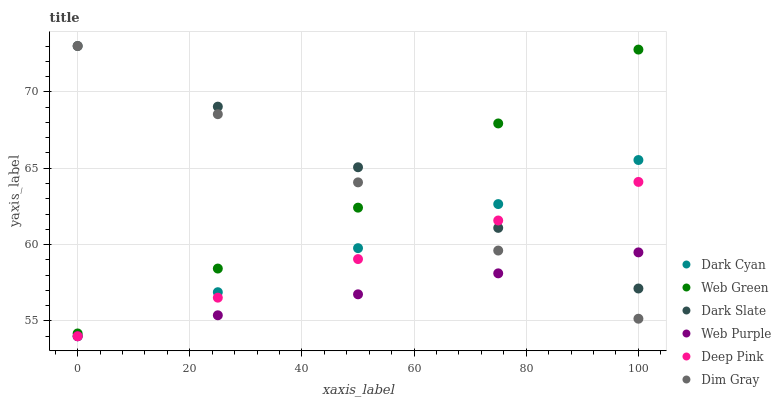Does Web Purple have the minimum area under the curve?
Answer yes or no. Yes. Does Dark Slate have the maximum area under the curve?
Answer yes or no. Yes. Does Web Green have the minimum area under the curve?
Answer yes or no. No. Does Web Green have the maximum area under the curve?
Answer yes or no. No. Is Dark Slate the smoothest?
Answer yes or no. Yes. Is Web Green the roughest?
Answer yes or no. Yes. Is Web Green the smoothest?
Answer yes or no. No. Is Dark Slate the roughest?
Answer yes or no. No. Does Deep Pink have the lowest value?
Answer yes or no. Yes. Does Web Green have the lowest value?
Answer yes or no. No. Does Dim Gray have the highest value?
Answer yes or no. Yes. Does Web Green have the highest value?
Answer yes or no. No. Is Web Purple less than Web Green?
Answer yes or no. Yes. Is Web Green greater than Dark Cyan?
Answer yes or no. Yes. Does Deep Pink intersect Dark Cyan?
Answer yes or no. Yes. Is Deep Pink less than Dark Cyan?
Answer yes or no. No. Is Deep Pink greater than Dark Cyan?
Answer yes or no. No. Does Web Purple intersect Web Green?
Answer yes or no. No. 